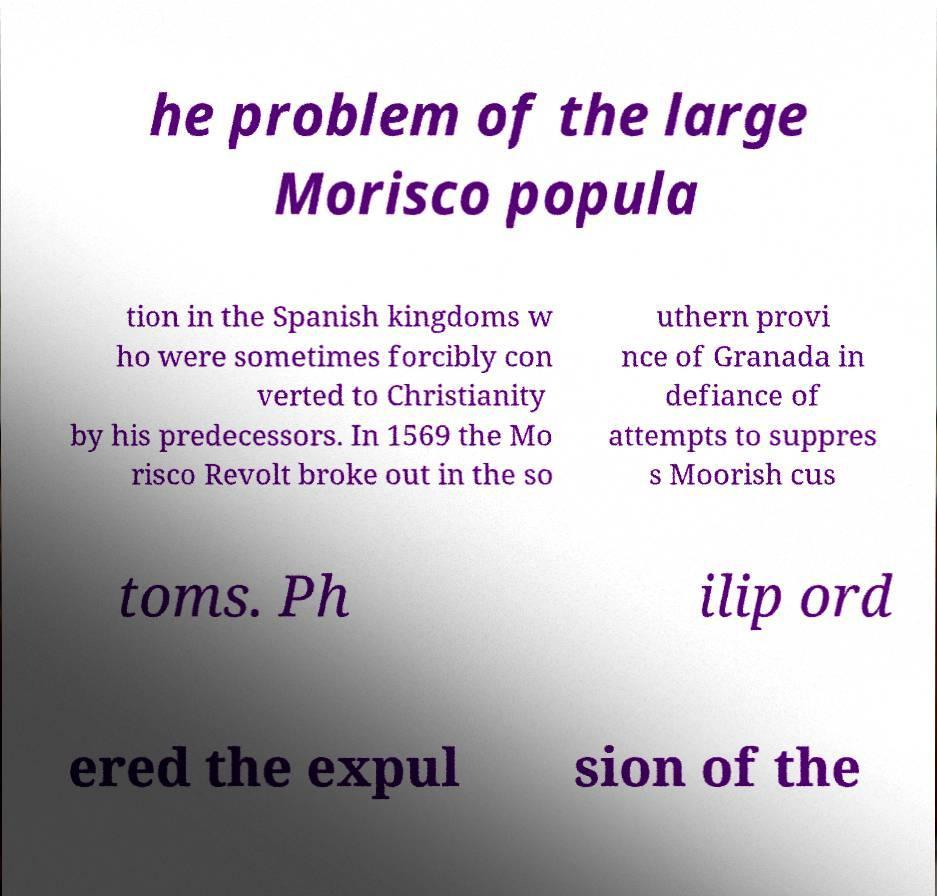Can you accurately transcribe the text from the provided image for me? he problem of the large Morisco popula tion in the Spanish kingdoms w ho were sometimes forcibly con verted to Christianity by his predecessors. In 1569 the Mo risco Revolt broke out in the so uthern provi nce of Granada in defiance of attempts to suppres s Moorish cus toms. Ph ilip ord ered the expul sion of the 